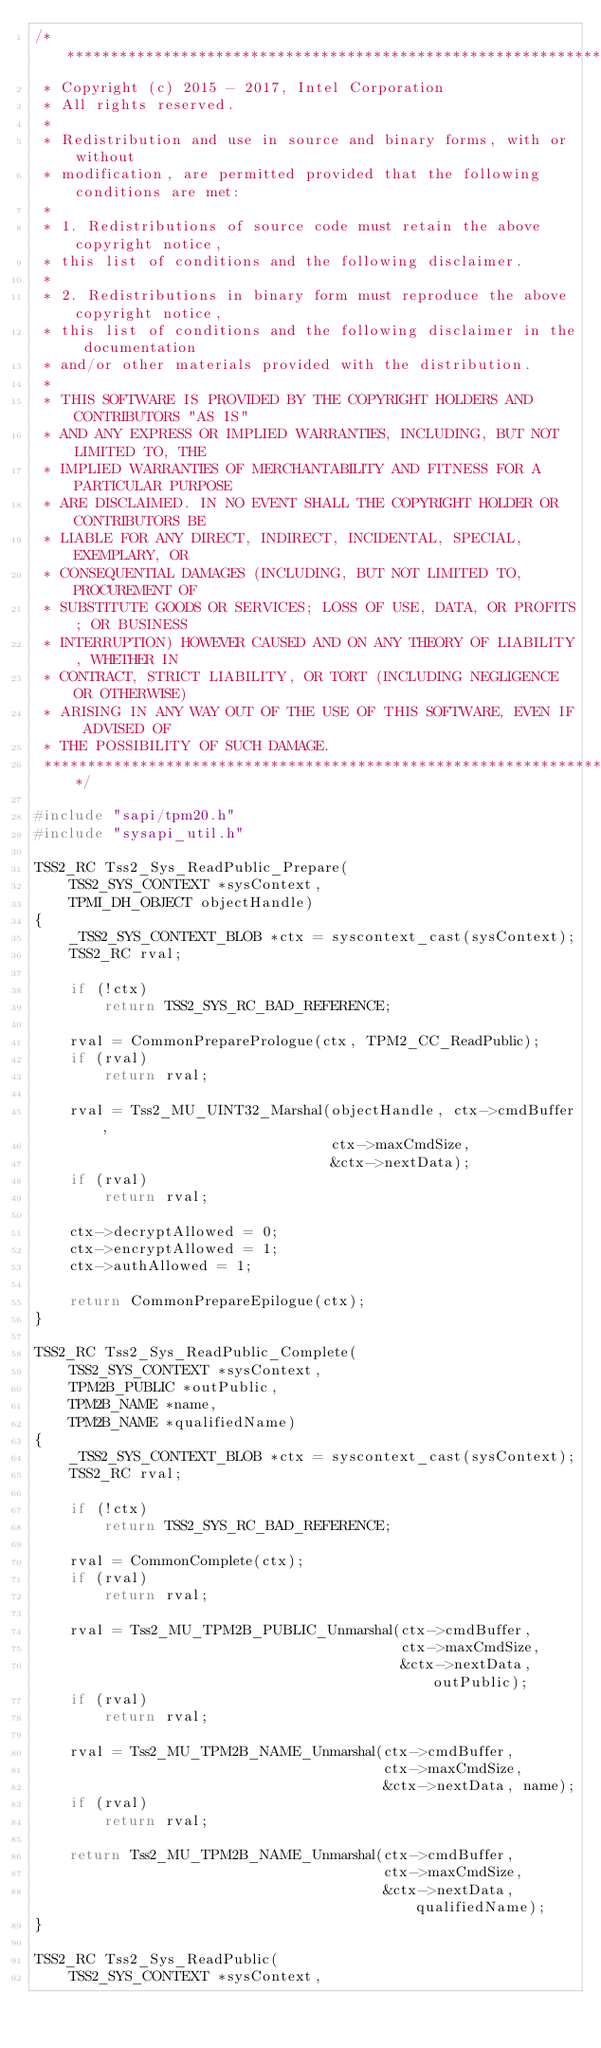<code> <loc_0><loc_0><loc_500><loc_500><_C_>/***********************************************************************;
 * Copyright (c) 2015 - 2017, Intel Corporation
 * All rights reserved.
 *
 * Redistribution and use in source and binary forms, with or without
 * modification, are permitted provided that the following conditions are met:
 *
 * 1. Redistributions of source code must retain the above copyright notice,
 * this list of conditions and the following disclaimer.
 *
 * 2. Redistributions in binary form must reproduce the above copyright notice,
 * this list of conditions and the following disclaimer in the documentation
 * and/or other materials provided with the distribution.
 *
 * THIS SOFTWARE IS PROVIDED BY THE COPYRIGHT HOLDERS AND CONTRIBUTORS "AS IS"
 * AND ANY EXPRESS OR IMPLIED WARRANTIES, INCLUDING, BUT NOT LIMITED TO, THE
 * IMPLIED WARRANTIES OF MERCHANTABILITY AND FITNESS FOR A PARTICULAR PURPOSE
 * ARE DISCLAIMED. IN NO EVENT SHALL THE COPYRIGHT HOLDER OR CONTRIBUTORS BE
 * LIABLE FOR ANY DIRECT, INDIRECT, INCIDENTAL, SPECIAL, EXEMPLARY, OR
 * CONSEQUENTIAL DAMAGES (INCLUDING, BUT NOT LIMITED TO, PROCUREMENT OF
 * SUBSTITUTE GOODS OR SERVICES; LOSS OF USE, DATA, OR PROFITS; OR BUSINESS
 * INTERRUPTION) HOWEVER CAUSED AND ON ANY THEORY OF LIABILITY, WHETHER IN
 * CONTRACT, STRICT LIABILITY, OR TORT (INCLUDING NEGLIGENCE OR OTHERWISE)
 * ARISING IN ANY WAY OUT OF THE USE OF THIS SOFTWARE, EVEN IF ADVISED OF
 * THE POSSIBILITY OF SUCH DAMAGE.
 ***********************************************************************/

#include "sapi/tpm20.h"
#include "sysapi_util.h"

TSS2_RC Tss2_Sys_ReadPublic_Prepare(
    TSS2_SYS_CONTEXT *sysContext,
    TPMI_DH_OBJECT objectHandle)
{
    _TSS2_SYS_CONTEXT_BLOB *ctx = syscontext_cast(sysContext);
    TSS2_RC rval;

    if (!ctx)
        return TSS2_SYS_RC_BAD_REFERENCE;

    rval = CommonPreparePrologue(ctx, TPM2_CC_ReadPublic);
    if (rval)
        return rval;

    rval = Tss2_MU_UINT32_Marshal(objectHandle, ctx->cmdBuffer,
                                  ctx->maxCmdSize,
                                  &ctx->nextData);
    if (rval)
        return rval;

    ctx->decryptAllowed = 0;
    ctx->encryptAllowed = 1;
    ctx->authAllowed = 1;

    return CommonPrepareEpilogue(ctx);
}

TSS2_RC Tss2_Sys_ReadPublic_Complete(
    TSS2_SYS_CONTEXT *sysContext,
    TPM2B_PUBLIC *outPublic,
    TPM2B_NAME *name,
    TPM2B_NAME *qualifiedName)
{
    _TSS2_SYS_CONTEXT_BLOB *ctx = syscontext_cast(sysContext);
    TSS2_RC rval;

    if (!ctx)
        return TSS2_SYS_RC_BAD_REFERENCE;

    rval = CommonComplete(ctx);
    if (rval)
        return rval;

    rval = Tss2_MU_TPM2B_PUBLIC_Unmarshal(ctx->cmdBuffer,
                                          ctx->maxCmdSize,
                                          &ctx->nextData, outPublic);
    if (rval)
        return rval;

    rval = Tss2_MU_TPM2B_NAME_Unmarshal(ctx->cmdBuffer,
                                        ctx->maxCmdSize,
                                        &ctx->nextData, name);
    if (rval)
        return rval;

    return Tss2_MU_TPM2B_NAME_Unmarshal(ctx->cmdBuffer,
                                        ctx->maxCmdSize,
                                        &ctx->nextData, qualifiedName);
}

TSS2_RC Tss2_Sys_ReadPublic(
    TSS2_SYS_CONTEXT *sysContext,</code> 